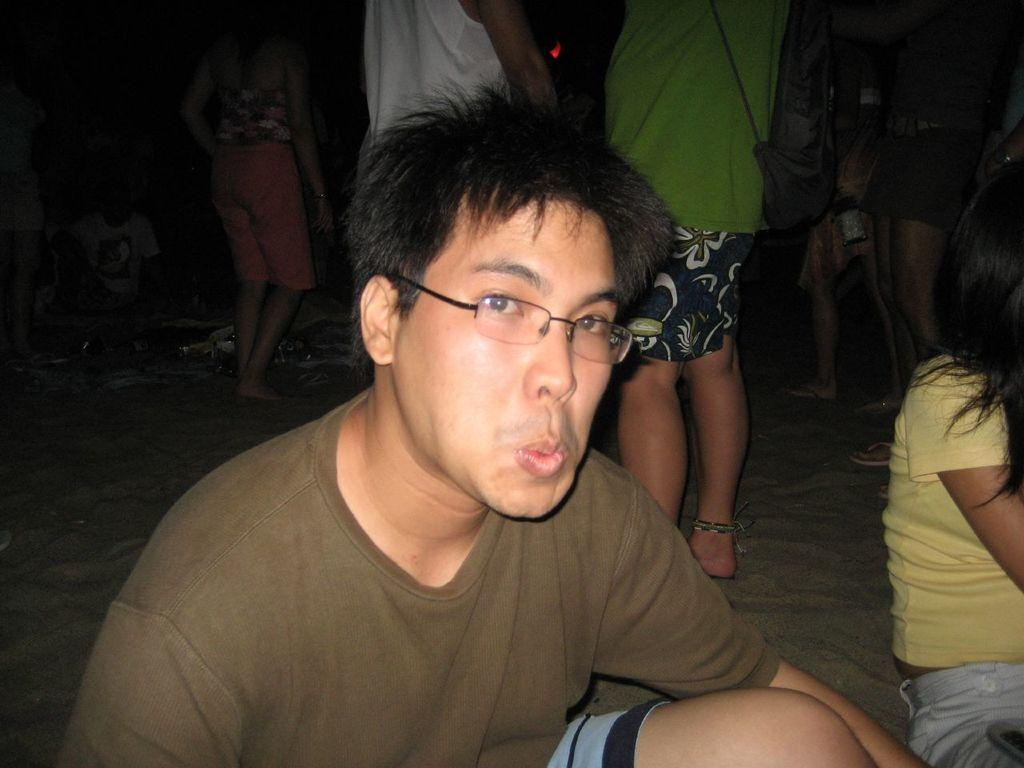What is the person in the image doing? The person is sitting in the image. What is the person wearing? The person is wearing a brown top. Can you describe the people in the background of the image? There are people standing in the background of the image, and one of them is wearing a black color bag. What type of stone is being used to start the car in the image? There is no car or stone present in the image. 